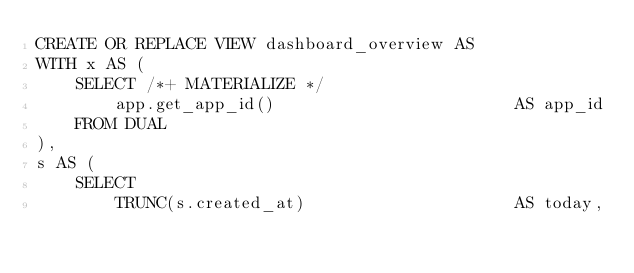Convert code to text. <code><loc_0><loc_0><loc_500><loc_500><_SQL_>CREATE OR REPLACE VIEW dashboard_overview AS
WITH x AS (
    SELECT /*+ MATERIALIZE */
        app.get_app_id()                        AS app_id
    FROM DUAL
),
s AS (
    SELECT
        TRUNC(s.created_at)                     AS today,</code> 